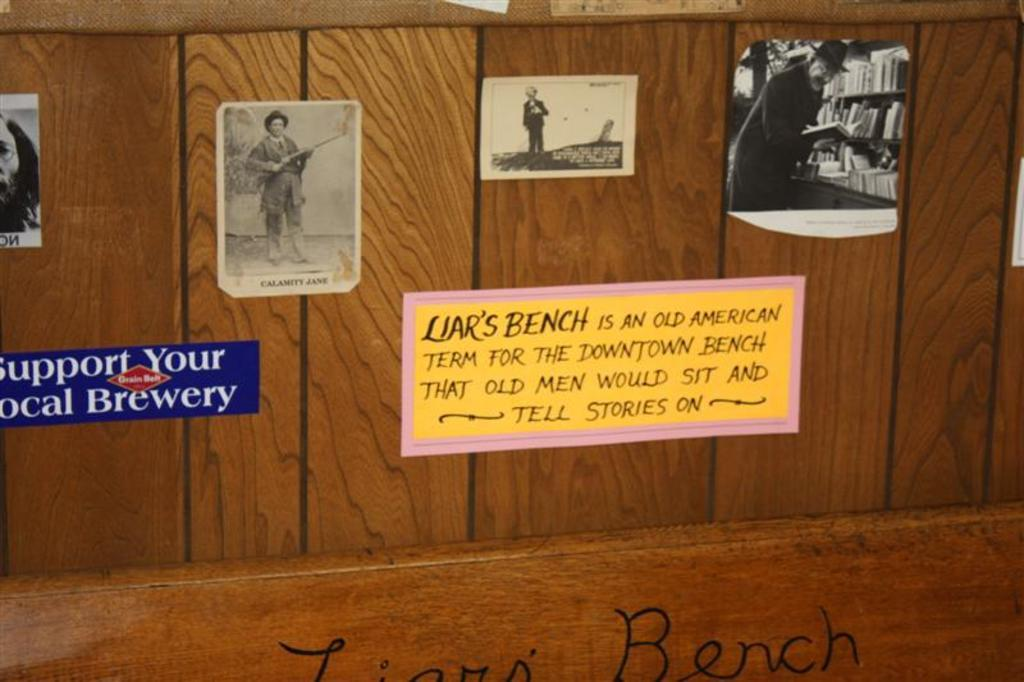<image>
Summarize the visual content of the image. A museum piece titled the Liar's Bench with a description of how it earned that name. 